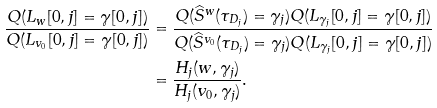<formula> <loc_0><loc_0><loc_500><loc_500>\frac { Q ( L _ { w } [ 0 , j ] = \gamma [ 0 , j ] ) } { Q ( L _ { v _ { 0 } } [ 0 , j ] = \gamma [ 0 , j ] ) } & = \frac { Q ( \widehat { S } ^ { w } ( \tau _ { D _ { j } } ) = \gamma _ { j } ) Q ( L _ { \gamma _ { j } } [ 0 , j ] = \gamma [ 0 , j ] ) } { Q ( \widehat { S } ^ { v _ { 0 } } ( \tau _ { D _ { j } } ) = \gamma _ { j } ) Q ( L _ { \gamma _ { j } } [ 0 , j ] = \gamma [ 0 , j ] ) } \\ & = \frac { H _ { j } ( w , \gamma _ { j } ) } { H _ { j } ( v _ { 0 } , \gamma _ { j } ) } .</formula> 